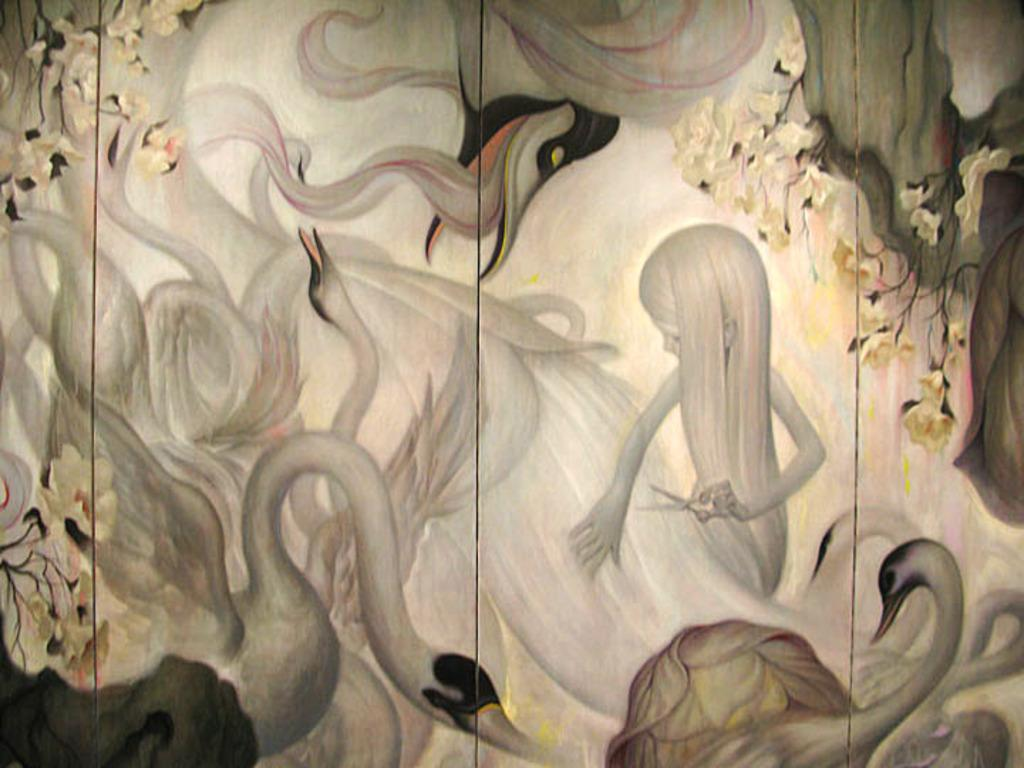What type of animals are depicted on the wall in the image? There are images of swans drawn on a wall in the image. What is the girl holding in the image? The girl is holding scissors in the image. Where is the girl positioned in relation to the swan images? The girl is positioned between the swan images. How many kittens are sitting on the girl's lap in the image? There are no kittens present in the image. What substance is being cut by the girl with the scissors? The image does not show the girl cutting any substance; she is simply holding scissors. 